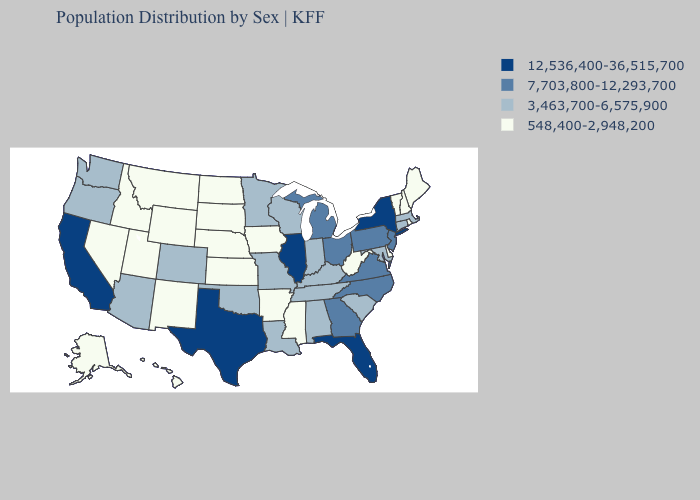Among the states that border Kansas , which have the highest value?
Short answer required. Colorado, Missouri, Oklahoma. What is the lowest value in states that border Utah?
Keep it brief. 548,400-2,948,200. Among the states that border Texas , which have the highest value?
Be succinct. Louisiana, Oklahoma. Name the states that have a value in the range 3,463,700-6,575,900?
Answer briefly. Alabama, Arizona, Colorado, Connecticut, Indiana, Kentucky, Louisiana, Maryland, Massachusetts, Minnesota, Missouri, Oklahoma, Oregon, South Carolina, Tennessee, Washington, Wisconsin. What is the highest value in the USA?
Answer briefly. 12,536,400-36,515,700. Does the first symbol in the legend represent the smallest category?
Answer briefly. No. Among the states that border Nevada , which have the highest value?
Concise answer only. California. What is the value of Nevada?
Be succinct. 548,400-2,948,200. Name the states that have a value in the range 12,536,400-36,515,700?
Short answer required. California, Florida, Illinois, New York, Texas. Among the states that border Rhode Island , which have the lowest value?
Concise answer only. Connecticut, Massachusetts. Is the legend a continuous bar?
Be succinct. No. What is the value of Texas?
Write a very short answer. 12,536,400-36,515,700. What is the lowest value in the MidWest?
Give a very brief answer. 548,400-2,948,200. Which states have the highest value in the USA?
Keep it brief. California, Florida, Illinois, New York, Texas. Name the states that have a value in the range 7,703,800-12,293,700?
Write a very short answer. Georgia, Michigan, New Jersey, North Carolina, Ohio, Pennsylvania, Virginia. 